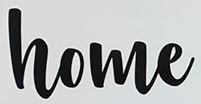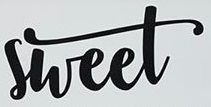What words can you see in these images in sequence, separated by a semicolon? home; sheet 